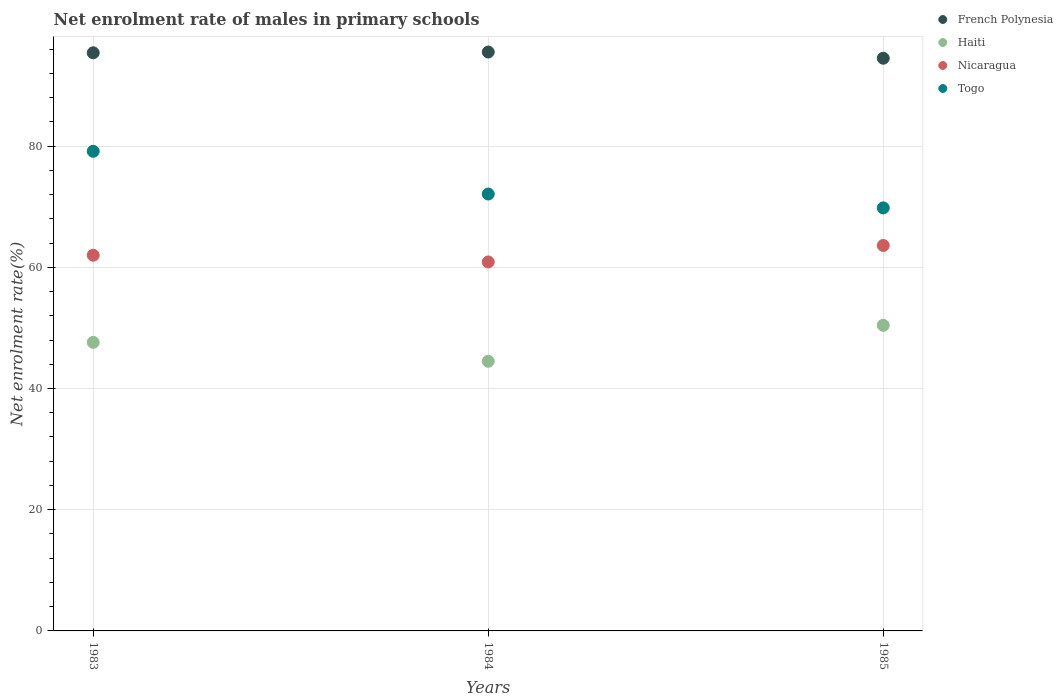How many different coloured dotlines are there?
Provide a succinct answer. 4. Is the number of dotlines equal to the number of legend labels?
Offer a very short reply. Yes. What is the net enrolment rate of males in primary schools in Haiti in 1983?
Offer a terse response. 47.62. Across all years, what is the maximum net enrolment rate of males in primary schools in Togo?
Make the answer very short. 79.14. Across all years, what is the minimum net enrolment rate of males in primary schools in Haiti?
Your answer should be compact. 44.5. In which year was the net enrolment rate of males in primary schools in French Polynesia minimum?
Provide a short and direct response. 1985. What is the total net enrolment rate of males in primary schools in Togo in the graph?
Your answer should be very brief. 221.04. What is the difference between the net enrolment rate of males in primary schools in French Polynesia in 1984 and that in 1985?
Your answer should be very brief. 1.02. What is the difference between the net enrolment rate of males in primary schools in French Polynesia in 1985 and the net enrolment rate of males in primary schools in Nicaragua in 1983?
Give a very brief answer. 32.51. What is the average net enrolment rate of males in primary schools in French Polynesia per year?
Provide a short and direct response. 95.14. In the year 1985, what is the difference between the net enrolment rate of males in primary schools in French Polynesia and net enrolment rate of males in primary schools in Nicaragua?
Give a very brief answer. 30.89. In how many years, is the net enrolment rate of males in primary schools in Nicaragua greater than 92 %?
Your answer should be very brief. 0. What is the ratio of the net enrolment rate of males in primary schools in Togo in 1983 to that in 1985?
Give a very brief answer. 1.13. Is the difference between the net enrolment rate of males in primary schools in French Polynesia in 1984 and 1985 greater than the difference between the net enrolment rate of males in primary schools in Nicaragua in 1984 and 1985?
Offer a terse response. Yes. What is the difference between the highest and the second highest net enrolment rate of males in primary schools in Haiti?
Your response must be concise. 2.81. What is the difference between the highest and the lowest net enrolment rate of males in primary schools in Haiti?
Ensure brevity in your answer.  5.93. In how many years, is the net enrolment rate of males in primary schools in French Polynesia greater than the average net enrolment rate of males in primary schools in French Polynesia taken over all years?
Offer a very short reply. 2. Is the net enrolment rate of males in primary schools in Togo strictly greater than the net enrolment rate of males in primary schools in Nicaragua over the years?
Your answer should be very brief. Yes. Is the net enrolment rate of males in primary schools in Togo strictly less than the net enrolment rate of males in primary schools in Haiti over the years?
Offer a very short reply. No. How many years are there in the graph?
Your answer should be compact. 3. What is the difference between two consecutive major ticks on the Y-axis?
Give a very brief answer. 20. Does the graph contain any zero values?
Your answer should be compact. No. Does the graph contain grids?
Provide a short and direct response. Yes. Where does the legend appear in the graph?
Offer a terse response. Top right. How are the legend labels stacked?
Your response must be concise. Vertical. What is the title of the graph?
Offer a terse response. Net enrolment rate of males in primary schools. What is the label or title of the X-axis?
Your answer should be very brief. Years. What is the label or title of the Y-axis?
Provide a succinct answer. Net enrolment rate(%). What is the Net enrolment rate(%) in French Polynesia in 1983?
Offer a very short reply. 95.4. What is the Net enrolment rate(%) in Haiti in 1983?
Keep it short and to the point. 47.62. What is the Net enrolment rate(%) in Nicaragua in 1983?
Your response must be concise. 61.99. What is the Net enrolment rate(%) in Togo in 1983?
Offer a very short reply. 79.14. What is the Net enrolment rate(%) in French Polynesia in 1984?
Keep it short and to the point. 95.52. What is the Net enrolment rate(%) of Haiti in 1984?
Ensure brevity in your answer.  44.5. What is the Net enrolment rate(%) in Nicaragua in 1984?
Provide a succinct answer. 60.88. What is the Net enrolment rate(%) in Togo in 1984?
Your answer should be very brief. 72.09. What is the Net enrolment rate(%) in French Polynesia in 1985?
Your answer should be very brief. 94.5. What is the Net enrolment rate(%) of Haiti in 1985?
Give a very brief answer. 50.43. What is the Net enrolment rate(%) in Nicaragua in 1985?
Your answer should be compact. 63.6. What is the Net enrolment rate(%) of Togo in 1985?
Offer a terse response. 69.8. Across all years, what is the maximum Net enrolment rate(%) in French Polynesia?
Offer a terse response. 95.52. Across all years, what is the maximum Net enrolment rate(%) in Haiti?
Offer a very short reply. 50.43. Across all years, what is the maximum Net enrolment rate(%) in Nicaragua?
Make the answer very short. 63.6. Across all years, what is the maximum Net enrolment rate(%) in Togo?
Give a very brief answer. 79.14. Across all years, what is the minimum Net enrolment rate(%) of French Polynesia?
Make the answer very short. 94.5. Across all years, what is the minimum Net enrolment rate(%) in Haiti?
Offer a terse response. 44.5. Across all years, what is the minimum Net enrolment rate(%) in Nicaragua?
Give a very brief answer. 60.88. Across all years, what is the minimum Net enrolment rate(%) in Togo?
Offer a terse response. 69.8. What is the total Net enrolment rate(%) of French Polynesia in the graph?
Provide a succinct answer. 285.42. What is the total Net enrolment rate(%) in Haiti in the graph?
Offer a very short reply. 142.54. What is the total Net enrolment rate(%) of Nicaragua in the graph?
Give a very brief answer. 186.48. What is the total Net enrolment rate(%) in Togo in the graph?
Provide a short and direct response. 221.04. What is the difference between the Net enrolment rate(%) of French Polynesia in 1983 and that in 1984?
Keep it short and to the point. -0.12. What is the difference between the Net enrolment rate(%) in Haiti in 1983 and that in 1984?
Your answer should be very brief. 3.12. What is the difference between the Net enrolment rate(%) of Nicaragua in 1983 and that in 1984?
Offer a terse response. 1.11. What is the difference between the Net enrolment rate(%) in Togo in 1983 and that in 1984?
Keep it short and to the point. 7.05. What is the difference between the Net enrolment rate(%) in French Polynesia in 1983 and that in 1985?
Offer a very short reply. 0.9. What is the difference between the Net enrolment rate(%) in Haiti in 1983 and that in 1985?
Your response must be concise. -2.81. What is the difference between the Net enrolment rate(%) in Nicaragua in 1983 and that in 1985?
Your answer should be compact. -1.61. What is the difference between the Net enrolment rate(%) of Togo in 1983 and that in 1985?
Your answer should be very brief. 9.34. What is the difference between the Net enrolment rate(%) in French Polynesia in 1984 and that in 1985?
Provide a short and direct response. 1.02. What is the difference between the Net enrolment rate(%) of Haiti in 1984 and that in 1985?
Your response must be concise. -5.93. What is the difference between the Net enrolment rate(%) of Nicaragua in 1984 and that in 1985?
Provide a succinct answer. -2.72. What is the difference between the Net enrolment rate(%) of Togo in 1984 and that in 1985?
Make the answer very short. 2.29. What is the difference between the Net enrolment rate(%) of French Polynesia in 1983 and the Net enrolment rate(%) of Haiti in 1984?
Provide a succinct answer. 50.9. What is the difference between the Net enrolment rate(%) in French Polynesia in 1983 and the Net enrolment rate(%) in Nicaragua in 1984?
Give a very brief answer. 34.51. What is the difference between the Net enrolment rate(%) in French Polynesia in 1983 and the Net enrolment rate(%) in Togo in 1984?
Your answer should be compact. 23.31. What is the difference between the Net enrolment rate(%) in Haiti in 1983 and the Net enrolment rate(%) in Nicaragua in 1984?
Give a very brief answer. -13.27. What is the difference between the Net enrolment rate(%) of Haiti in 1983 and the Net enrolment rate(%) of Togo in 1984?
Give a very brief answer. -24.48. What is the difference between the Net enrolment rate(%) in Nicaragua in 1983 and the Net enrolment rate(%) in Togo in 1984?
Give a very brief answer. -10.1. What is the difference between the Net enrolment rate(%) in French Polynesia in 1983 and the Net enrolment rate(%) in Haiti in 1985?
Provide a short and direct response. 44.97. What is the difference between the Net enrolment rate(%) of French Polynesia in 1983 and the Net enrolment rate(%) of Nicaragua in 1985?
Provide a succinct answer. 31.79. What is the difference between the Net enrolment rate(%) in French Polynesia in 1983 and the Net enrolment rate(%) in Togo in 1985?
Your answer should be very brief. 25.59. What is the difference between the Net enrolment rate(%) in Haiti in 1983 and the Net enrolment rate(%) in Nicaragua in 1985?
Provide a short and direct response. -15.99. What is the difference between the Net enrolment rate(%) of Haiti in 1983 and the Net enrolment rate(%) of Togo in 1985?
Your answer should be compact. -22.19. What is the difference between the Net enrolment rate(%) of Nicaragua in 1983 and the Net enrolment rate(%) of Togo in 1985?
Offer a terse response. -7.81. What is the difference between the Net enrolment rate(%) in French Polynesia in 1984 and the Net enrolment rate(%) in Haiti in 1985?
Provide a succinct answer. 45.09. What is the difference between the Net enrolment rate(%) of French Polynesia in 1984 and the Net enrolment rate(%) of Nicaragua in 1985?
Ensure brevity in your answer.  31.92. What is the difference between the Net enrolment rate(%) of French Polynesia in 1984 and the Net enrolment rate(%) of Togo in 1985?
Your response must be concise. 25.72. What is the difference between the Net enrolment rate(%) of Haiti in 1984 and the Net enrolment rate(%) of Nicaragua in 1985?
Offer a terse response. -19.11. What is the difference between the Net enrolment rate(%) of Haiti in 1984 and the Net enrolment rate(%) of Togo in 1985?
Your answer should be compact. -25.31. What is the difference between the Net enrolment rate(%) of Nicaragua in 1984 and the Net enrolment rate(%) of Togo in 1985?
Give a very brief answer. -8.92. What is the average Net enrolment rate(%) in French Polynesia per year?
Keep it short and to the point. 95.14. What is the average Net enrolment rate(%) in Haiti per year?
Your answer should be compact. 47.51. What is the average Net enrolment rate(%) in Nicaragua per year?
Offer a terse response. 62.16. What is the average Net enrolment rate(%) of Togo per year?
Keep it short and to the point. 73.68. In the year 1983, what is the difference between the Net enrolment rate(%) in French Polynesia and Net enrolment rate(%) in Haiti?
Your answer should be very brief. 47.78. In the year 1983, what is the difference between the Net enrolment rate(%) in French Polynesia and Net enrolment rate(%) in Nicaragua?
Make the answer very short. 33.41. In the year 1983, what is the difference between the Net enrolment rate(%) in French Polynesia and Net enrolment rate(%) in Togo?
Give a very brief answer. 16.26. In the year 1983, what is the difference between the Net enrolment rate(%) in Haiti and Net enrolment rate(%) in Nicaragua?
Keep it short and to the point. -14.38. In the year 1983, what is the difference between the Net enrolment rate(%) of Haiti and Net enrolment rate(%) of Togo?
Give a very brief answer. -31.52. In the year 1983, what is the difference between the Net enrolment rate(%) in Nicaragua and Net enrolment rate(%) in Togo?
Your response must be concise. -17.15. In the year 1984, what is the difference between the Net enrolment rate(%) of French Polynesia and Net enrolment rate(%) of Haiti?
Offer a terse response. 51.03. In the year 1984, what is the difference between the Net enrolment rate(%) in French Polynesia and Net enrolment rate(%) in Nicaragua?
Provide a succinct answer. 34.64. In the year 1984, what is the difference between the Net enrolment rate(%) in French Polynesia and Net enrolment rate(%) in Togo?
Keep it short and to the point. 23.43. In the year 1984, what is the difference between the Net enrolment rate(%) in Haiti and Net enrolment rate(%) in Nicaragua?
Offer a terse response. -16.39. In the year 1984, what is the difference between the Net enrolment rate(%) in Haiti and Net enrolment rate(%) in Togo?
Ensure brevity in your answer.  -27.6. In the year 1984, what is the difference between the Net enrolment rate(%) of Nicaragua and Net enrolment rate(%) of Togo?
Give a very brief answer. -11.21. In the year 1985, what is the difference between the Net enrolment rate(%) in French Polynesia and Net enrolment rate(%) in Haiti?
Keep it short and to the point. 44.07. In the year 1985, what is the difference between the Net enrolment rate(%) of French Polynesia and Net enrolment rate(%) of Nicaragua?
Ensure brevity in your answer.  30.89. In the year 1985, what is the difference between the Net enrolment rate(%) of French Polynesia and Net enrolment rate(%) of Togo?
Offer a very short reply. 24.7. In the year 1985, what is the difference between the Net enrolment rate(%) of Haiti and Net enrolment rate(%) of Nicaragua?
Provide a short and direct response. -13.17. In the year 1985, what is the difference between the Net enrolment rate(%) in Haiti and Net enrolment rate(%) in Togo?
Offer a very short reply. -19.37. In the year 1985, what is the difference between the Net enrolment rate(%) of Nicaragua and Net enrolment rate(%) of Togo?
Your response must be concise. -6.2. What is the ratio of the Net enrolment rate(%) of Haiti in 1983 to that in 1984?
Your response must be concise. 1.07. What is the ratio of the Net enrolment rate(%) in Nicaragua in 1983 to that in 1984?
Keep it short and to the point. 1.02. What is the ratio of the Net enrolment rate(%) of Togo in 1983 to that in 1984?
Provide a short and direct response. 1.1. What is the ratio of the Net enrolment rate(%) in French Polynesia in 1983 to that in 1985?
Keep it short and to the point. 1.01. What is the ratio of the Net enrolment rate(%) in Haiti in 1983 to that in 1985?
Your response must be concise. 0.94. What is the ratio of the Net enrolment rate(%) in Nicaragua in 1983 to that in 1985?
Your answer should be compact. 0.97. What is the ratio of the Net enrolment rate(%) in Togo in 1983 to that in 1985?
Your answer should be very brief. 1.13. What is the ratio of the Net enrolment rate(%) of French Polynesia in 1984 to that in 1985?
Your answer should be very brief. 1.01. What is the ratio of the Net enrolment rate(%) of Haiti in 1984 to that in 1985?
Make the answer very short. 0.88. What is the ratio of the Net enrolment rate(%) in Nicaragua in 1984 to that in 1985?
Your response must be concise. 0.96. What is the ratio of the Net enrolment rate(%) in Togo in 1984 to that in 1985?
Offer a very short reply. 1.03. What is the difference between the highest and the second highest Net enrolment rate(%) of French Polynesia?
Offer a terse response. 0.12. What is the difference between the highest and the second highest Net enrolment rate(%) of Haiti?
Offer a terse response. 2.81. What is the difference between the highest and the second highest Net enrolment rate(%) of Nicaragua?
Make the answer very short. 1.61. What is the difference between the highest and the second highest Net enrolment rate(%) of Togo?
Your answer should be very brief. 7.05. What is the difference between the highest and the lowest Net enrolment rate(%) in French Polynesia?
Make the answer very short. 1.02. What is the difference between the highest and the lowest Net enrolment rate(%) in Haiti?
Give a very brief answer. 5.93. What is the difference between the highest and the lowest Net enrolment rate(%) of Nicaragua?
Offer a very short reply. 2.72. What is the difference between the highest and the lowest Net enrolment rate(%) in Togo?
Provide a succinct answer. 9.34. 